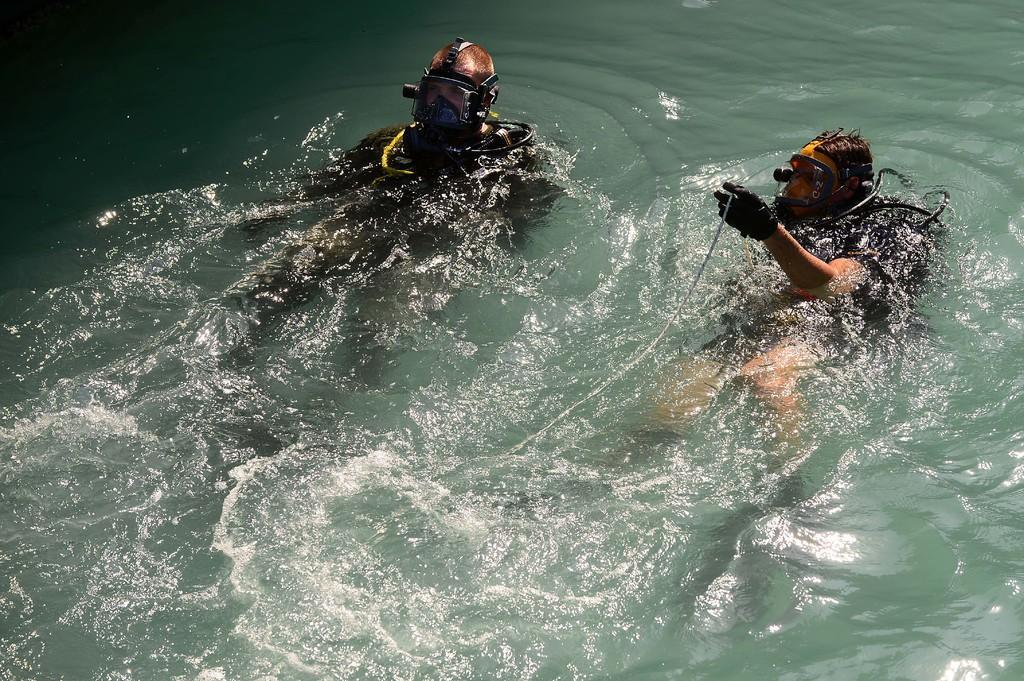How would you summarize this image in a sentence or two? In this picture we can see some water. In the water there are two persons. 